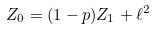<formula> <loc_0><loc_0><loc_500><loc_500>Z _ { 0 } = ( 1 - p ) Z _ { 1 } + \ell ^ { 2 }</formula> 